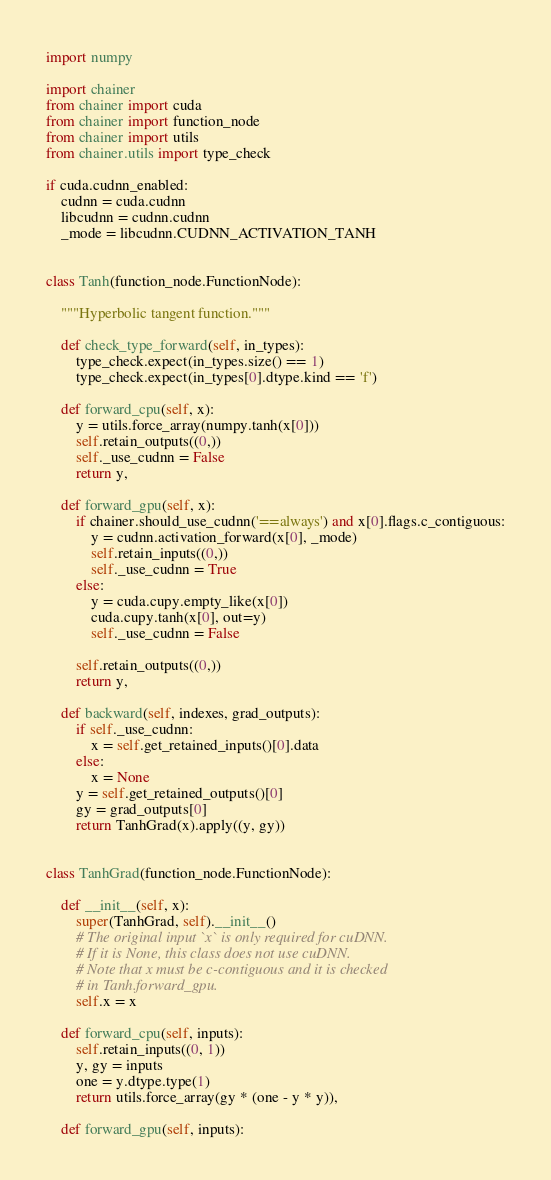<code> <loc_0><loc_0><loc_500><loc_500><_Python_>import numpy

import chainer
from chainer import cuda
from chainer import function_node
from chainer import utils
from chainer.utils import type_check

if cuda.cudnn_enabled:
    cudnn = cuda.cudnn
    libcudnn = cudnn.cudnn
    _mode = libcudnn.CUDNN_ACTIVATION_TANH


class Tanh(function_node.FunctionNode):

    """Hyperbolic tangent function."""

    def check_type_forward(self, in_types):
        type_check.expect(in_types.size() == 1)
        type_check.expect(in_types[0].dtype.kind == 'f')

    def forward_cpu(self, x):
        y = utils.force_array(numpy.tanh(x[0]))
        self.retain_outputs((0,))
        self._use_cudnn = False
        return y,

    def forward_gpu(self, x):
        if chainer.should_use_cudnn('==always') and x[0].flags.c_contiguous:
            y = cudnn.activation_forward(x[0], _mode)
            self.retain_inputs((0,))
            self._use_cudnn = True
        else:
            y = cuda.cupy.empty_like(x[0])
            cuda.cupy.tanh(x[0], out=y)
            self._use_cudnn = False

        self.retain_outputs((0,))
        return y,

    def backward(self, indexes, grad_outputs):
        if self._use_cudnn:
            x = self.get_retained_inputs()[0].data
        else:
            x = None
        y = self.get_retained_outputs()[0]
        gy = grad_outputs[0]
        return TanhGrad(x).apply((y, gy))


class TanhGrad(function_node.FunctionNode):

    def __init__(self, x):
        super(TanhGrad, self).__init__()
        # The original input `x` is only required for cuDNN.
        # If it is None, this class does not use cuDNN.
        # Note that x must be c-contiguous and it is checked
        # in Tanh.forward_gpu.
        self.x = x

    def forward_cpu(self, inputs):
        self.retain_inputs((0, 1))
        y, gy = inputs
        one = y.dtype.type(1)
        return utils.force_array(gy * (one - y * y)),

    def forward_gpu(self, inputs):</code> 